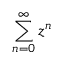Convert formula to latex. <formula><loc_0><loc_0><loc_500><loc_500>\sum _ { n = 0 } ^ { \infty } z ^ { n }</formula> 